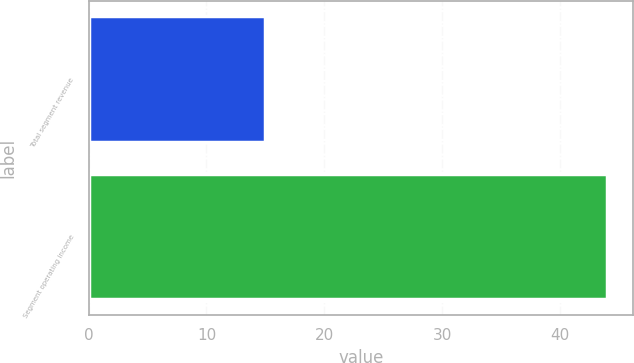Convert chart to OTSL. <chart><loc_0><loc_0><loc_500><loc_500><bar_chart><fcel>Total segment revenue<fcel>Segment operating income<nl><fcel>15<fcel>44<nl></chart> 